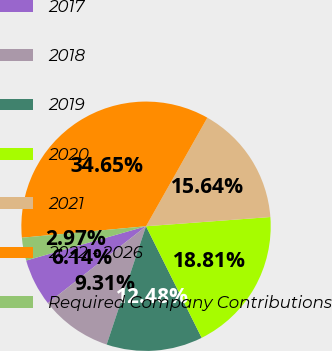Convert chart to OTSL. <chart><loc_0><loc_0><loc_500><loc_500><pie_chart><fcel>2017<fcel>2018<fcel>2019<fcel>2020<fcel>2021<fcel>2022 - 2026<fcel>Required Company Contributions<nl><fcel>6.14%<fcel>9.31%<fcel>12.48%<fcel>18.81%<fcel>15.64%<fcel>34.65%<fcel>2.97%<nl></chart> 